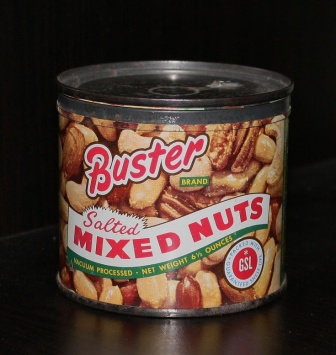 In the image, we see a cylinder can of Buster brand salted mixed nuts from a slightly tilted angle. The can, sealed securely by a black lid, is a visual treat for snack lovers. The label is colorful with a combination of rich red, white, and yellow hues, boldly declaring 'Buster Brand Salted Mixed Nuts'. What might be the context in which this image was taken? The image appears to have been taken in a setting meant to highlight the product's appeal, possibly for promotional or advertising purposes. The dark, wooden surface provides a contrasting background that makes the brightly colored label pop, emphasizing the can's presence and attractiveness. Imagine the nuts in the can could talk. What conversation might they be having? Pecan: "Hey, Almond, do you think we will be someone's snack today?"
Almond: "Oh, I'm sure of it! Just look at our label, we look irresistible."
Cashew: "I heard that our new packaging design is a hit. We're the talk of the snack aisle!"
Pecan: "I just love it when we're appreciated. Nothing beats making someone’s day a little bit nuttier!"
Almond: "Absolutely! To happy snacking and satisfied customers forever!" Besides advertising, what realistic scenario could this image be used for? This image could be used for an online product listing on a grocery or retail website. The clear and attractive presentation of the product helps potential buyers see exactly what they are purchasing, enhancing the likelihood of a sale. Describe a short but appealing story where this can of nuts plays a crucial role. A young chef, aiming to impress judges at a cooking competition, decides to create a gourmet salad using these Buster Brand Salted Mixed Nuts. The vibrant mix of pecans, almonds, and cashews adds a delightful crunch and flavor that perfectly complements the fresh greens and tangy dressing. Thanks to the delicious nuts, the chef wins first place and gains recognition for their innovative recipe. 